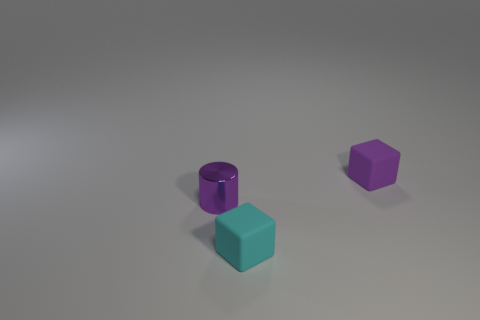What is the material of the tiny purple cylinder?
Your answer should be compact. Metal. How many large things are either brown matte spheres or purple matte blocks?
Provide a short and direct response. 0. There is a shiny cylinder; what number of tiny purple things are on the right side of it?
Your answer should be very brief. 1. Are there any small rubber objects that have the same color as the tiny cylinder?
Your answer should be very brief. Yes. There is a matte object that is the same size as the cyan block; what shape is it?
Your answer should be compact. Cube. What number of green things are large cylinders or cylinders?
Your answer should be very brief. 0. How many cyan spheres have the same size as the purple block?
Make the answer very short. 0. There is a small rubber thing that is the same color as the metal cylinder; what shape is it?
Provide a succinct answer. Cube. How many things are either small cyan matte cubes or blocks that are on the left side of the purple cube?
Keep it short and to the point. 1. Is the size of the block that is in front of the purple matte thing the same as the block behind the tiny cyan cube?
Keep it short and to the point. Yes. 